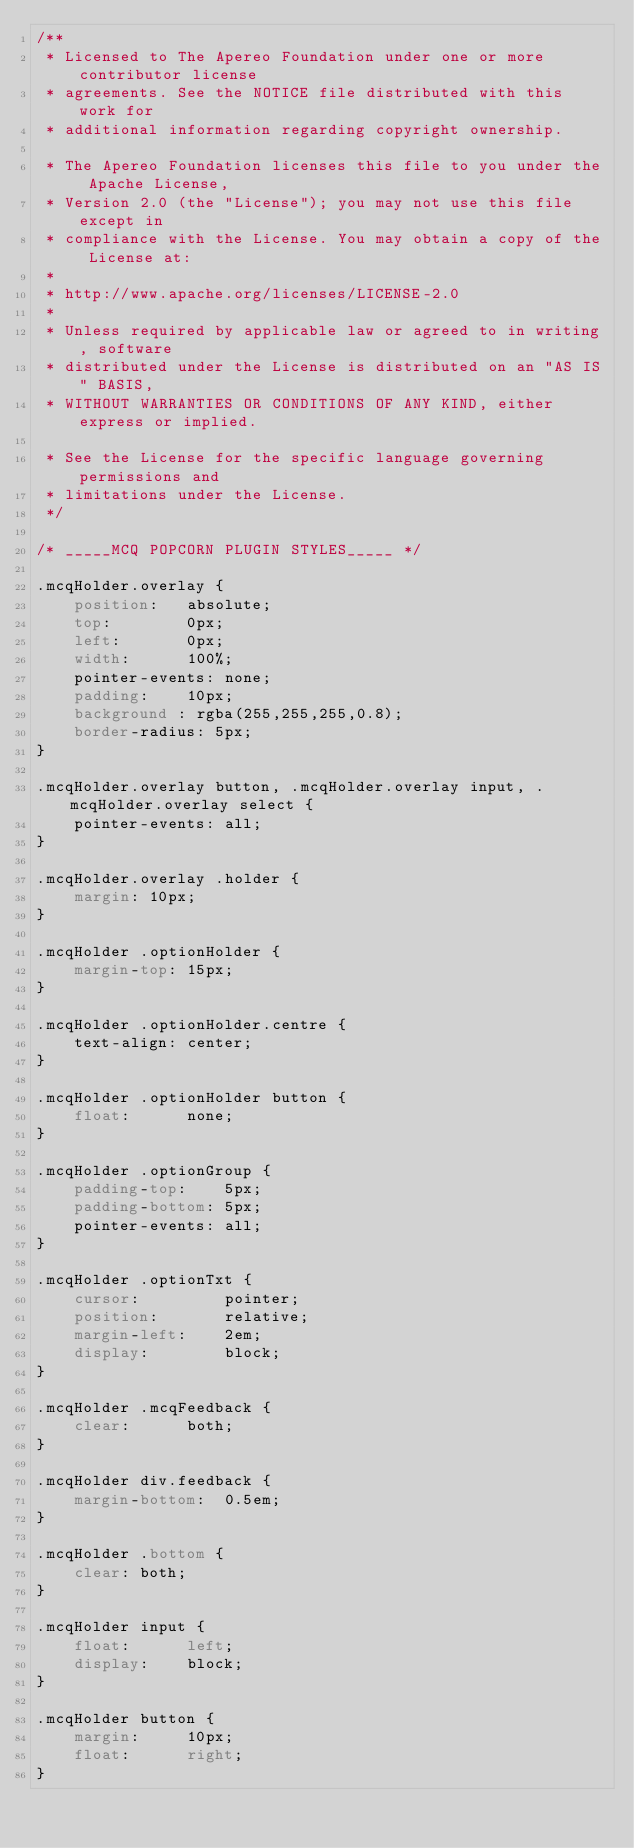<code> <loc_0><loc_0><loc_500><loc_500><_CSS_>/**
 * Licensed to The Apereo Foundation under one or more contributor license
 * agreements. See the NOTICE file distributed with this work for
 * additional information regarding copyright ownership.

 * The Apereo Foundation licenses this file to you under the Apache License,
 * Version 2.0 (the "License"); you may not use this file except in
 * compliance with the License. You may obtain a copy of the License at:
 *
 * http://www.apache.org/licenses/LICENSE-2.0
 * 
 * Unless required by applicable law or agreed to in writing, software
 * distributed under the License is distributed on an "AS IS" BASIS,
 * WITHOUT WARRANTIES OR CONDITIONS OF ANY KIND, either express or implied.

 * See the License for the specific language governing permissions and
 * limitations under the License.
 */

/* _____MCQ POPCORN PLUGIN STYLES_____ */

.mcqHolder.overlay {
	position:	absolute;
	top:		0px;
	left:		0px;
	width:		100%;
	pointer-events: none;
	padding:    10px;
	background : rgba(255,255,255,0.8);
	border-radius: 5px;
}

.mcqHolder.overlay button, .mcqHolder.overlay input, .mcqHolder.overlay select {
	pointer-events: all;
}

.mcqHolder.overlay .holder {
	margin:	10px;
}

.mcqHolder .optionHolder {
	margin-top:	15px;
}

.mcqHolder .optionHolder.centre {
	text-align:	center;
}

.mcqHolder .optionHolder button {
	float:		none;
}

.mcqHolder .optionGroup {
	padding-top:	5px;
	padding-bottom:	5px;
	pointer-events: all;
}

.mcqHolder .optionTxt {
	cursor:			pointer;
	position:		relative;
	margin-left:	2em;
	display:		block;
}

.mcqHolder .mcqFeedback {
	clear:		both;
}

.mcqHolder div.feedback {
	margin-bottom:	0.5em;
}

.mcqHolder .bottom {
	clear: both;
}

.mcqHolder input {
	float:		left;
	display:	block;
}

.mcqHolder button {
	margin:		10px;
	float:		right;
}</code> 